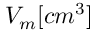Convert formula to latex. <formula><loc_0><loc_0><loc_500><loc_500>V _ { m } [ c m ^ { 3 } ]</formula> 